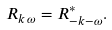Convert formula to latex. <formula><loc_0><loc_0><loc_500><loc_500>R _ { { k } \, \omega } = R _ { { - k } - \omega } ^ { * } .</formula> 